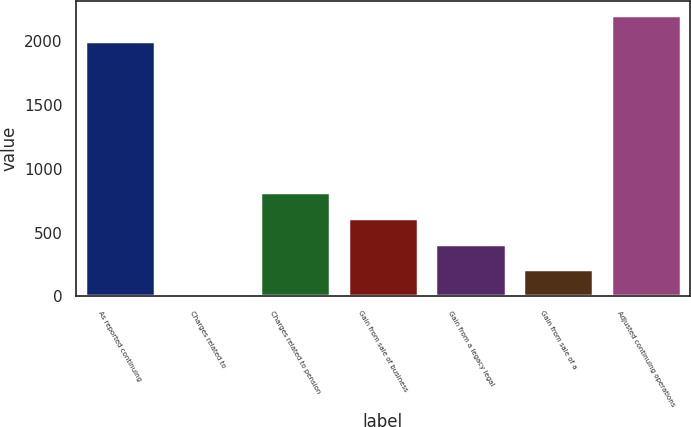Convert chart. <chart><loc_0><loc_0><loc_500><loc_500><bar_chart><fcel>As reported continuing<fcel>Charges related to<fcel>Charges related to pension<fcel>Gain from sale of business<fcel>Gain from a legacy legal<fcel>Gain from sale of a<fcel>Adjusted continuing operations<nl><fcel>2005<fcel>9<fcel>815.4<fcel>613.8<fcel>412.2<fcel>210.6<fcel>2206.6<nl></chart> 